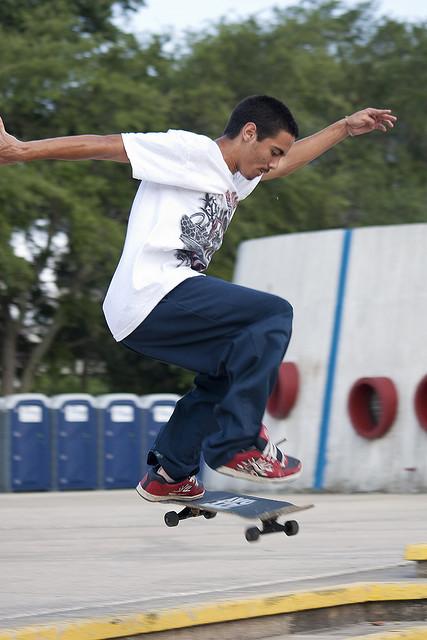What color is the skateboard?
Quick response, please. Black. Is he wearing a hat?
Answer briefly. No. Is this guy wearing skinny jeans?
Give a very brief answer. No. Is this man skateboarding?
Answer briefly. Yes. What color are the wheels?
Give a very brief answer. Black. What is the man doing?
Short answer required. Skateboarding. 